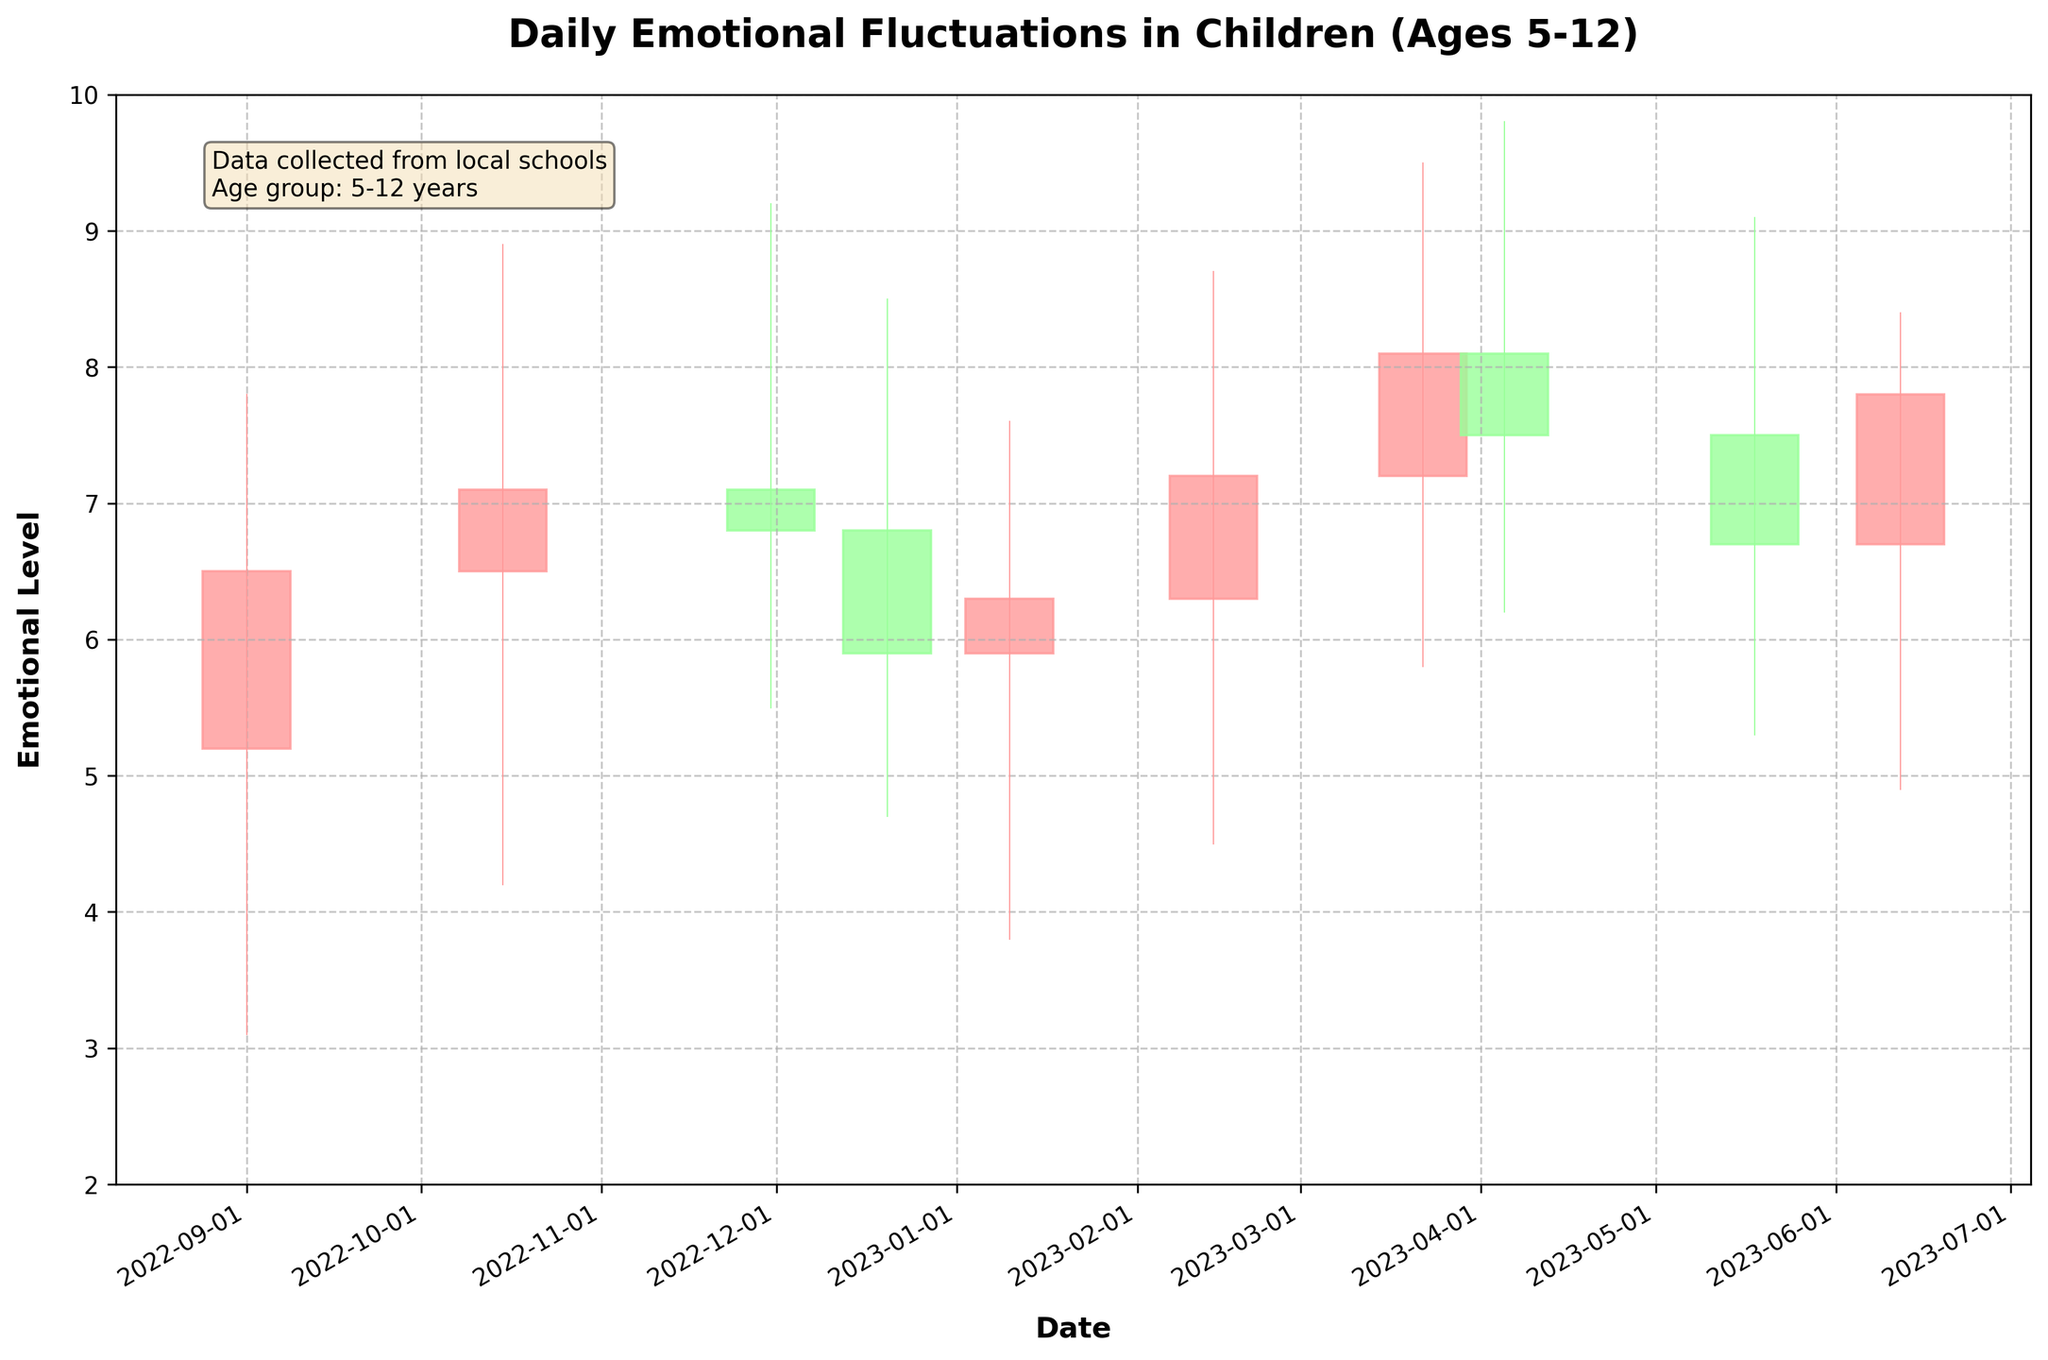What is the highest emotional level recorded in the chart? Look at the "High" values on the y-axis and find the peak value. The highest high value recorded is 9.8.
Answer: 9.8 On which date did the children experience the lowest emotional level, and what was that level? Find the lowest "Low" value on the chart and identify the corresponding date. The lowest emotional level recorded was 3.1 on 2022-09-01.
Answer: 2022-09-01, 3.1 What is the range of emotional levels on 2022-11-30? Identify the "High" and "Low" values for 2022-11-30. The range is calculated by subtracting the low value (5.5) from the high value (9.2).
Answer: 3.7 Which date shows the most significant increase in emotional level from the opening to the closing? Calculate the difference between the "Open" and "Close" values for each date and identify the largest positive difference. On 2023-03-22, the difference between the open (7.2) and close (8.1) is 0.9, the largest increase.
Answer: 2023-03-22 Comparing the dates 2022-10-15 and 2023-05-18, which date had a higher closing emotional level? Look at the "Close" values for both dates and compare them. The closing emotional level for 2022-10-15 is 7.1, and for 2023-05-18, it is 6.7.
Answer: 2022-10-15 What was the average opening emotional level over the entire school year? Sum the "Open" values for all dates and divide by the total number of dates (10). The values sum to 66.2, and the average is 66.2/10
Answer: 6.62 Which month shows the highest closing emotional level? Examine the "Close" values for each date and identify the highest value's corresponding month. The highest closing value (8.1) occurs in March 2023.
Answer: March 2023 Was there any month where the emotional level was consistently increasing from open to close? Check each month by comparing "Open" and "Close" values to see if they consistently rise. Only the month of February (2023-02-14) shows an increase from open (6.3) to close (7.2).
Answer: February How many times did the closing emotional level decrease compared to the opening level? Count the instances where the "Close" value is lower than the "Open" value. There are 4 instances (2022-11-30, 2022-12-20, 2023-05-18, and 2023-06-12).
Answer: 4 On which date did the children experience the smallest range of emotional fluctuations? Find the date where the difference between "High" and "Low" is the smallest. On 2022-12-20, the range is the smallest, with a high of 8.5 and a low of 4.7, resulting in a range of 3.8.
Answer: 2022-12-20 